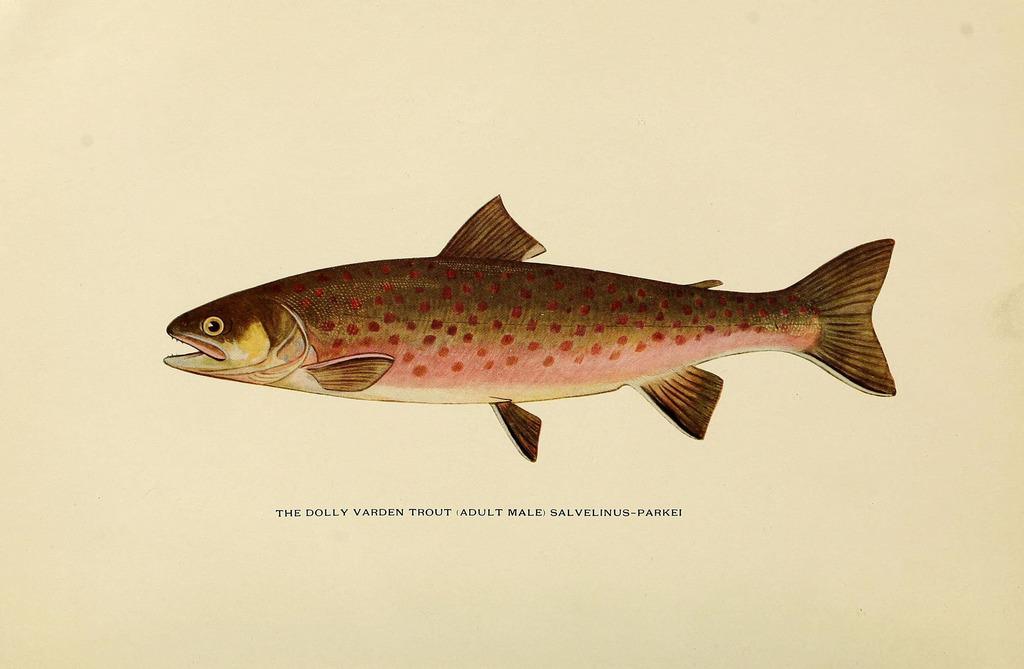Describe this image in one or two sentences. In this picture I can see the fish. I can see the text. 